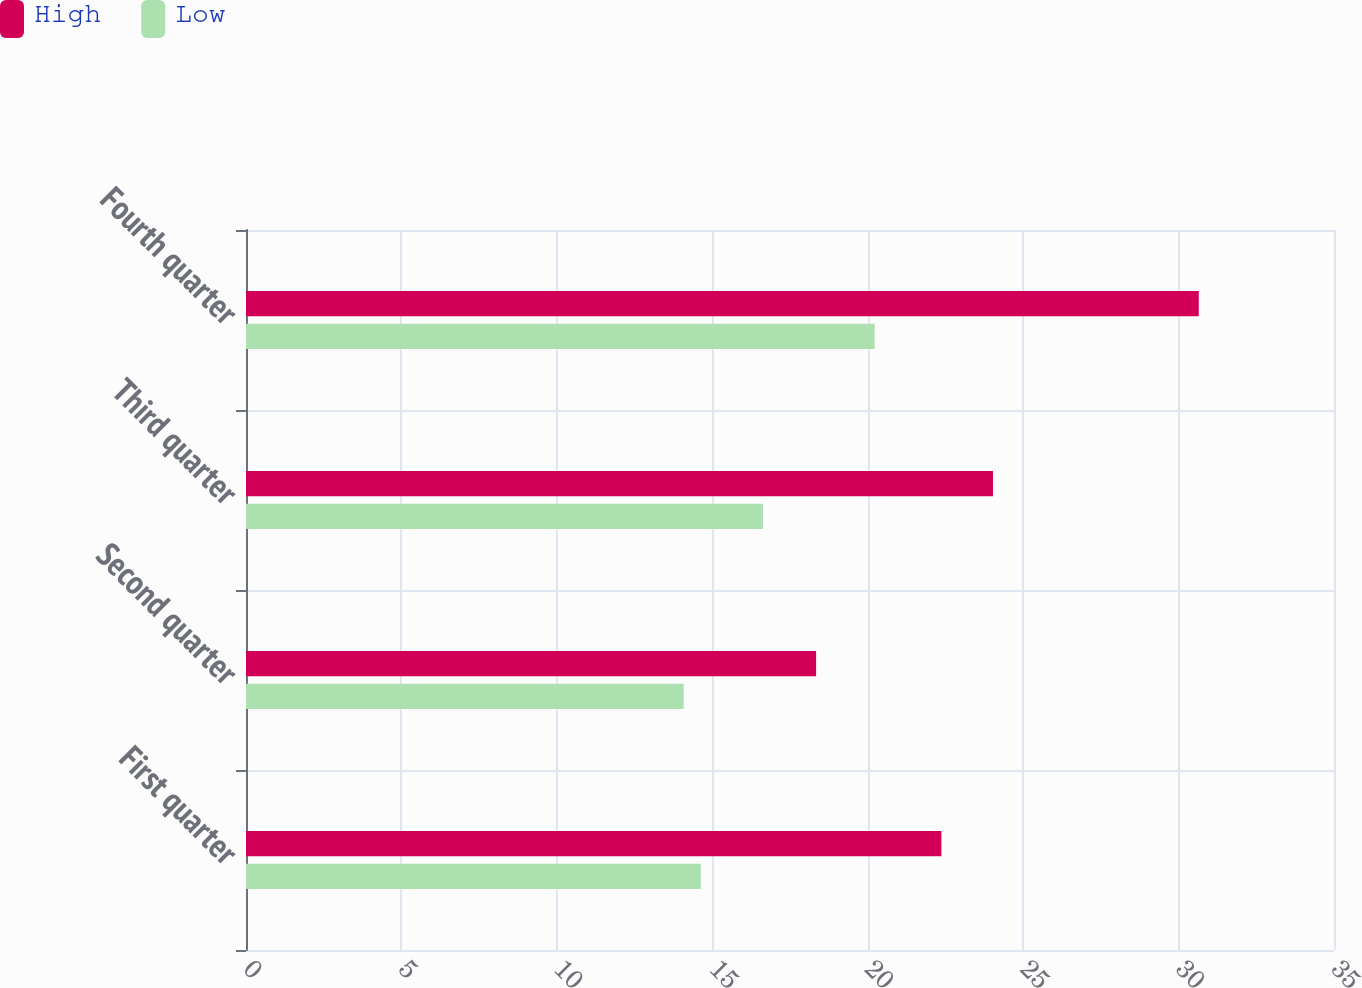Convert chart to OTSL. <chart><loc_0><loc_0><loc_500><loc_500><stacked_bar_chart><ecel><fcel>First quarter<fcel>Second quarter<fcel>Third quarter<fcel>Fourth quarter<nl><fcel>High<fcel>22.37<fcel>18.34<fcel>24.03<fcel>30.65<nl><fcel>Low<fcel>14.63<fcel>14.08<fcel>16.63<fcel>20.22<nl></chart> 